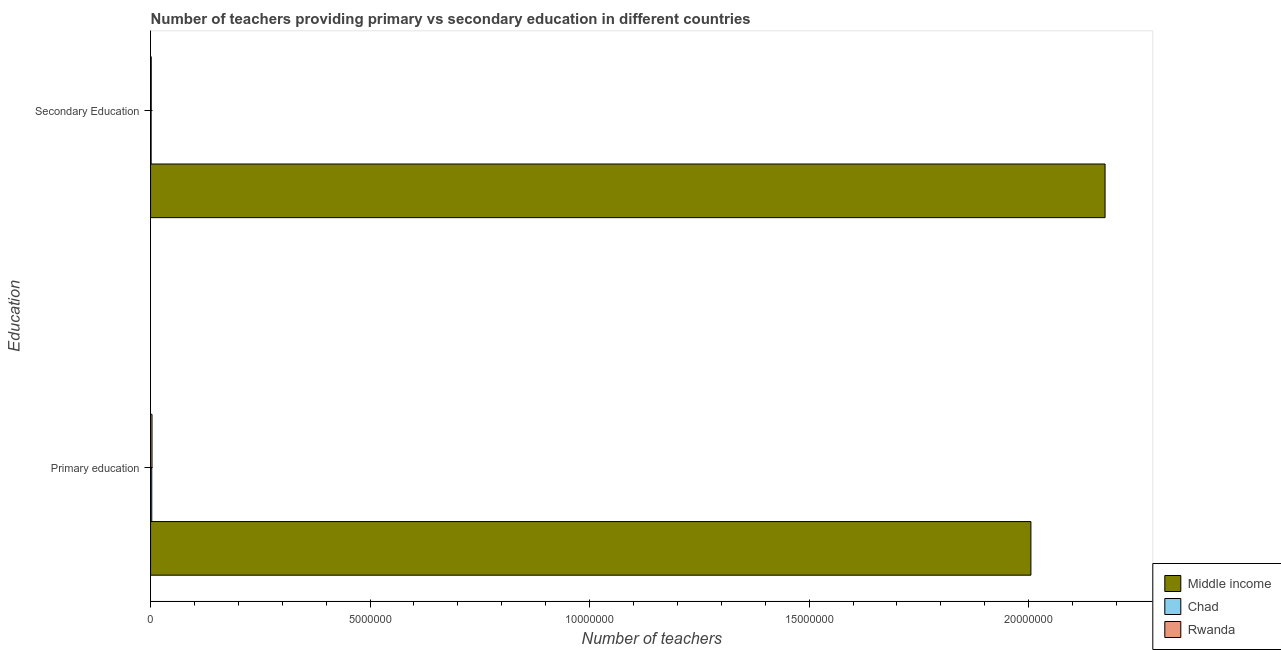How many different coloured bars are there?
Provide a succinct answer. 3. How many groups of bars are there?
Your answer should be very brief. 2. Are the number of bars per tick equal to the number of legend labels?
Make the answer very short. Yes. Are the number of bars on each tick of the Y-axis equal?
Provide a succinct answer. Yes. What is the label of the 1st group of bars from the top?
Give a very brief answer. Secondary Education. What is the number of primary teachers in Chad?
Offer a terse response. 2.74e+04. Across all countries, what is the maximum number of primary teachers?
Offer a terse response. 2.01e+07. Across all countries, what is the minimum number of secondary teachers?
Your answer should be very brief. 1.30e+04. In which country was the number of secondary teachers maximum?
Provide a succinct answer. Middle income. In which country was the number of secondary teachers minimum?
Ensure brevity in your answer.  Chad. What is the total number of secondary teachers in the graph?
Give a very brief answer. 2.18e+07. What is the difference between the number of secondary teachers in Chad and that in Middle income?
Provide a succinct answer. -2.17e+07. What is the difference between the number of secondary teachers in Rwanda and the number of primary teachers in Middle income?
Give a very brief answer. -2.00e+07. What is the average number of primary teachers per country?
Keep it short and to the point. 6.70e+06. What is the difference between the number of secondary teachers and number of primary teachers in Rwanda?
Your answer should be very brief. -1.78e+04. What is the ratio of the number of primary teachers in Rwanda to that in Middle income?
Provide a succinct answer. 0. What does the 3rd bar from the top in Primary education represents?
Your response must be concise. Middle income. What does the 2nd bar from the bottom in Secondary Education represents?
Keep it short and to the point. Chad. How many bars are there?
Provide a short and direct response. 6. Are all the bars in the graph horizontal?
Ensure brevity in your answer.  Yes. What is the difference between two consecutive major ticks on the X-axis?
Give a very brief answer. 5.00e+06. Are the values on the major ticks of X-axis written in scientific E-notation?
Your answer should be compact. No. Does the graph contain any zero values?
Your answer should be compact. No. How are the legend labels stacked?
Your answer should be compact. Vertical. What is the title of the graph?
Your answer should be very brief. Number of teachers providing primary vs secondary education in different countries. Does "Ecuador" appear as one of the legend labels in the graph?
Give a very brief answer. No. What is the label or title of the X-axis?
Offer a very short reply. Number of teachers. What is the label or title of the Y-axis?
Ensure brevity in your answer.  Education. What is the Number of teachers in Middle income in Primary education?
Your answer should be very brief. 2.01e+07. What is the Number of teachers of Chad in Primary education?
Provide a short and direct response. 2.74e+04. What is the Number of teachers in Rwanda in Primary education?
Your answer should be compact. 3.32e+04. What is the Number of teachers of Middle income in Secondary Education?
Your answer should be very brief. 2.17e+07. What is the Number of teachers in Chad in Secondary Education?
Your answer should be compact. 1.30e+04. What is the Number of teachers in Rwanda in Secondary Education?
Make the answer very short. 1.53e+04. Across all Education, what is the maximum Number of teachers of Middle income?
Ensure brevity in your answer.  2.17e+07. Across all Education, what is the maximum Number of teachers in Chad?
Ensure brevity in your answer.  2.74e+04. Across all Education, what is the maximum Number of teachers of Rwanda?
Offer a very short reply. 3.32e+04. Across all Education, what is the minimum Number of teachers in Middle income?
Offer a very short reply. 2.01e+07. Across all Education, what is the minimum Number of teachers of Chad?
Offer a terse response. 1.30e+04. Across all Education, what is the minimum Number of teachers of Rwanda?
Keep it short and to the point. 1.53e+04. What is the total Number of teachers of Middle income in the graph?
Your answer should be compact. 4.18e+07. What is the total Number of teachers of Chad in the graph?
Make the answer very short. 4.04e+04. What is the total Number of teachers in Rwanda in the graph?
Offer a terse response. 4.85e+04. What is the difference between the Number of teachers of Middle income in Primary education and that in Secondary Education?
Provide a short and direct response. -1.69e+06. What is the difference between the Number of teachers of Chad in Primary education and that in Secondary Education?
Offer a terse response. 1.43e+04. What is the difference between the Number of teachers of Rwanda in Primary education and that in Secondary Education?
Offer a very short reply. 1.78e+04. What is the difference between the Number of teachers of Middle income in Primary education and the Number of teachers of Chad in Secondary Education?
Your answer should be compact. 2.00e+07. What is the difference between the Number of teachers in Middle income in Primary education and the Number of teachers in Rwanda in Secondary Education?
Keep it short and to the point. 2.00e+07. What is the difference between the Number of teachers of Chad in Primary education and the Number of teachers of Rwanda in Secondary Education?
Ensure brevity in your answer.  1.21e+04. What is the average Number of teachers of Middle income per Education?
Offer a very short reply. 2.09e+07. What is the average Number of teachers in Chad per Education?
Make the answer very short. 2.02e+04. What is the average Number of teachers of Rwanda per Education?
Make the answer very short. 2.42e+04. What is the difference between the Number of teachers of Middle income and Number of teachers of Chad in Primary education?
Offer a very short reply. 2.00e+07. What is the difference between the Number of teachers of Middle income and Number of teachers of Rwanda in Primary education?
Make the answer very short. 2.00e+07. What is the difference between the Number of teachers in Chad and Number of teachers in Rwanda in Primary education?
Offer a very short reply. -5770. What is the difference between the Number of teachers in Middle income and Number of teachers in Chad in Secondary Education?
Your answer should be very brief. 2.17e+07. What is the difference between the Number of teachers in Middle income and Number of teachers in Rwanda in Secondary Education?
Make the answer very short. 2.17e+07. What is the difference between the Number of teachers in Chad and Number of teachers in Rwanda in Secondary Education?
Give a very brief answer. -2286. What is the ratio of the Number of teachers in Middle income in Primary education to that in Secondary Education?
Make the answer very short. 0.92. What is the ratio of the Number of teachers of Chad in Primary education to that in Secondary Education?
Provide a short and direct response. 2.1. What is the ratio of the Number of teachers in Rwanda in Primary education to that in Secondary Education?
Your response must be concise. 2.16. What is the difference between the highest and the second highest Number of teachers of Middle income?
Offer a terse response. 1.69e+06. What is the difference between the highest and the second highest Number of teachers in Chad?
Your answer should be compact. 1.43e+04. What is the difference between the highest and the second highest Number of teachers in Rwanda?
Keep it short and to the point. 1.78e+04. What is the difference between the highest and the lowest Number of teachers in Middle income?
Offer a terse response. 1.69e+06. What is the difference between the highest and the lowest Number of teachers of Chad?
Offer a terse response. 1.43e+04. What is the difference between the highest and the lowest Number of teachers of Rwanda?
Provide a short and direct response. 1.78e+04. 